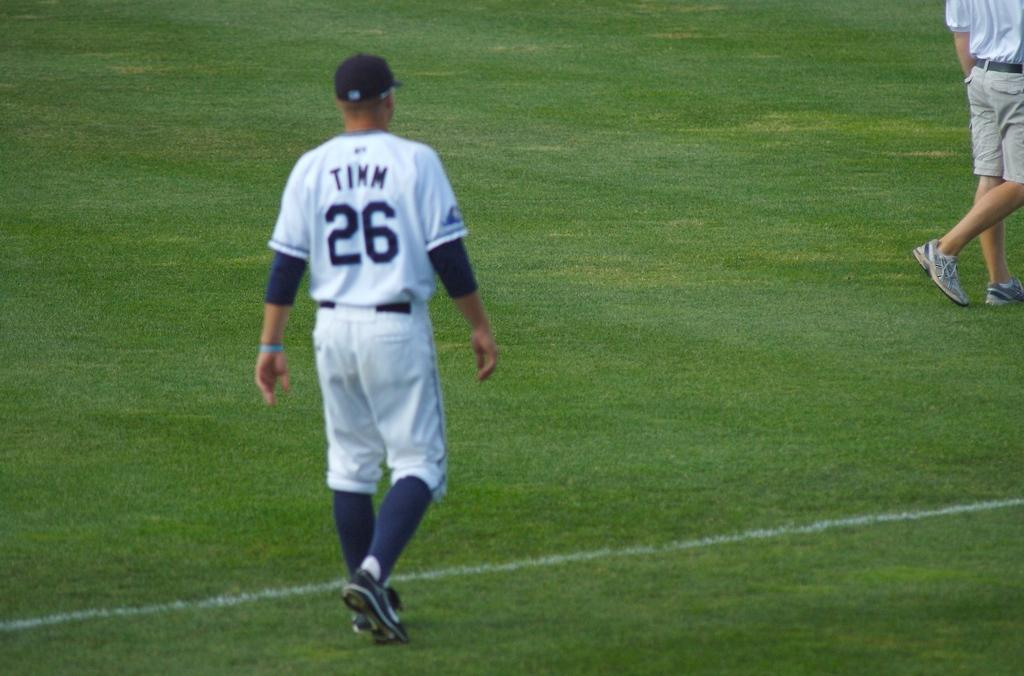<image>
Offer a succinct explanation of the picture presented. Baseball player walking along the foul line, his number is Timm # 26. 